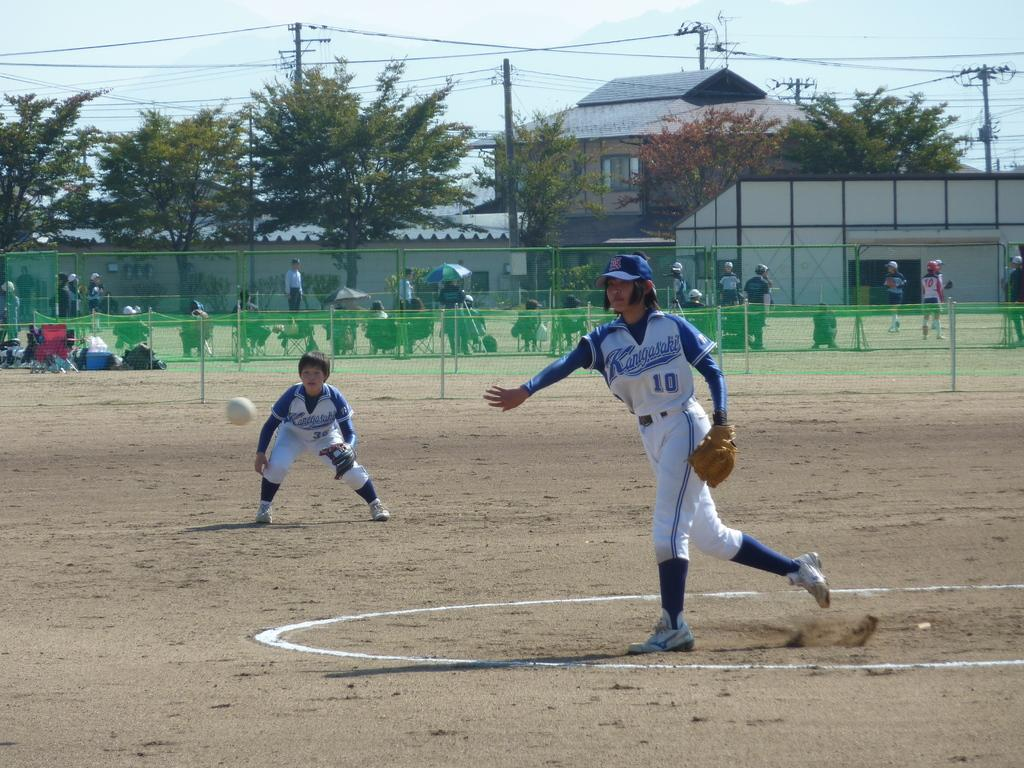Provide a one-sentence caption for the provided image. A player wearing a Kangasaki jersey throws the ball. 